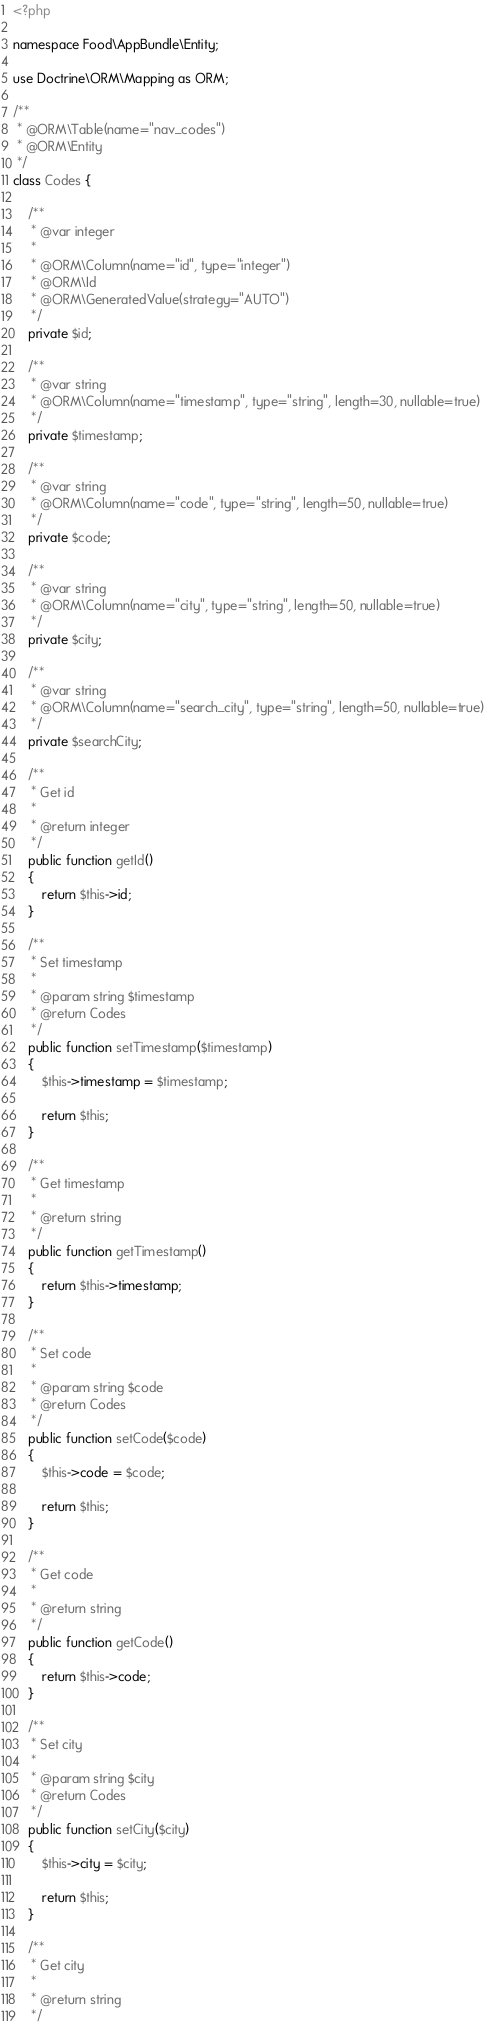Convert code to text. <code><loc_0><loc_0><loc_500><loc_500><_PHP_><?php

namespace Food\AppBundle\Entity;

use Doctrine\ORM\Mapping as ORM;

/**
 * @ORM\Table(name="nav_codes")
 * @ORM\Entity
 */
class Codes {

    /**
     * @var integer
     *
     * @ORM\Column(name="id", type="integer")
     * @ORM\Id
     * @ORM\GeneratedValue(strategy="AUTO")
     */
    private $id;

    /**
     * @var string
     * @ORM\Column(name="timestamp", type="string", length=30, nullable=true)
     */
    private $timestamp;

    /**
     * @var string
     * @ORM\Column(name="code", type="string", length=50, nullable=true)
     */
    private $code;

    /**
     * @var string
     * @ORM\Column(name="city", type="string", length=50, nullable=true)
     */
    private $city;

    /**
     * @var string
     * @ORM\Column(name="search_city", type="string", length=50, nullable=true)
     */
    private $searchCity;

    /**
     * Get id
     *
     * @return integer 
     */
    public function getId()
    {
        return $this->id;
    }

    /**
     * Set timestamp
     *
     * @param string $timestamp
     * @return Codes
     */
    public function setTimestamp($timestamp)
    {
        $this->timestamp = $timestamp;
    
        return $this;
    }

    /**
     * Get timestamp
     *
     * @return string 
     */
    public function getTimestamp()
    {
        return $this->timestamp;
    }

    /**
     * Set code
     *
     * @param string $code
     * @return Codes
     */
    public function setCode($code)
    {
        $this->code = $code;
    
        return $this;
    }

    /**
     * Get code
     *
     * @return string 
     */
    public function getCode()
    {
        return $this->code;
    }

    /**
     * Set city
     *
     * @param string $city
     * @return Codes
     */
    public function setCity($city)
    {
        $this->city = $city;
    
        return $this;
    }

    /**
     * Get city
     *
     * @return string 
     */</code> 